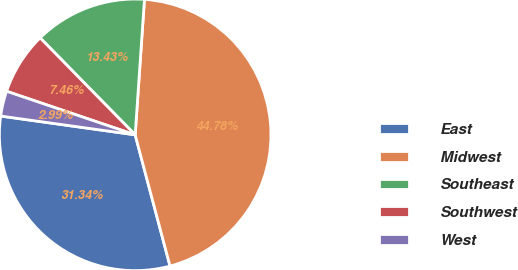Convert chart. <chart><loc_0><loc_0><loc_500><loc_500><pie_chart><fcel>East<fcel>Midwest<fcel>Southeast<fcel>Southwest<fcel>West<nl><fcel>31.34%<fcel>44.78%<fcel>13.43%<fcel>7.46%<fcel>2.99%<nl></chart> 